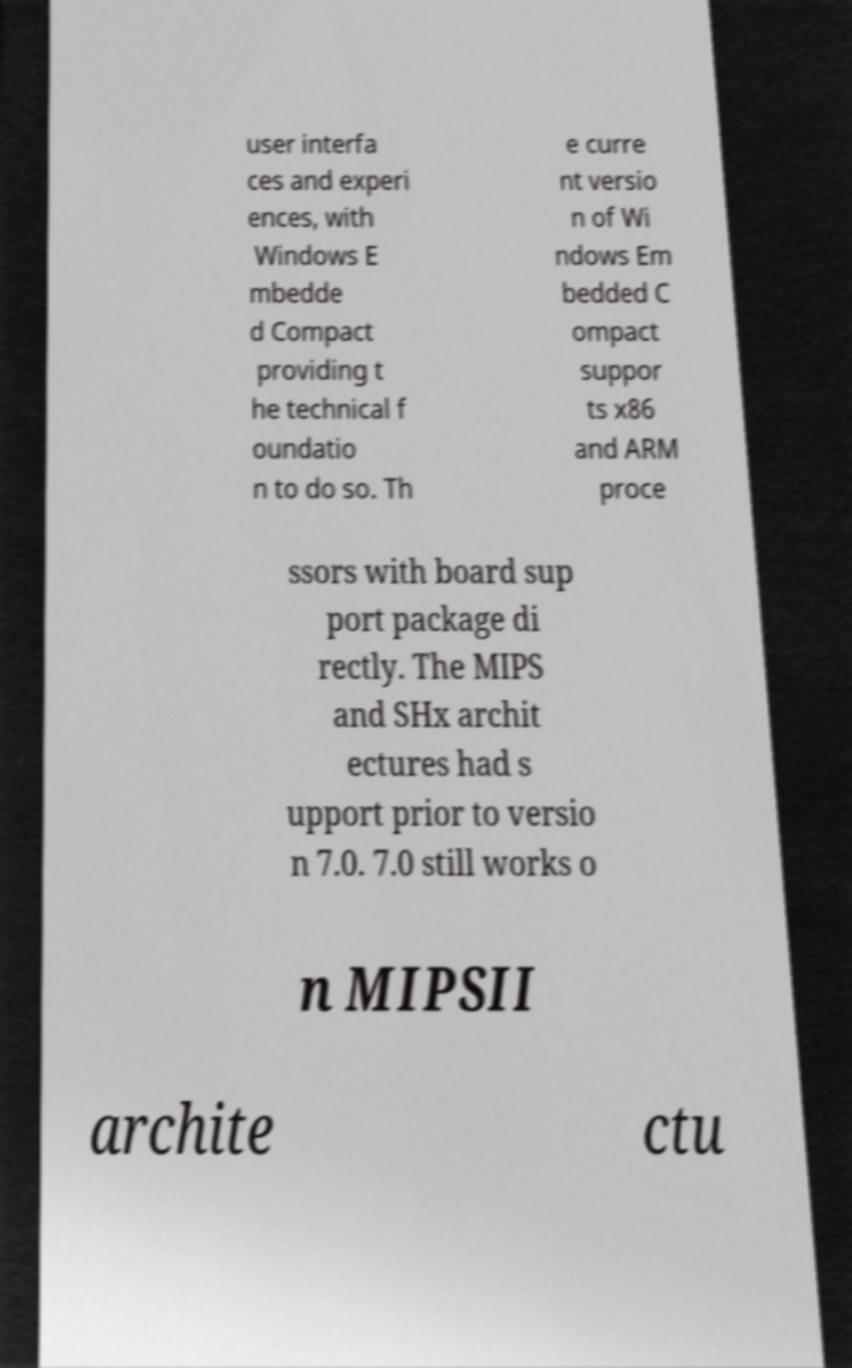Can you accurately transcribe the text from the provided image for me? user interfa ces and experi ences, with Windows E mbedde d Compact providing t he technical f oundatio n to do so. Th e curre nt versio n of Wi ndows Em bedded C ompact suppor ts x86 and ARM proce ssors with board sup port package di rectly. The MIPS and SHx archit ectures had s upport prior to versio n 7.0. 7.0 still works o n MIPSII archite ctu 